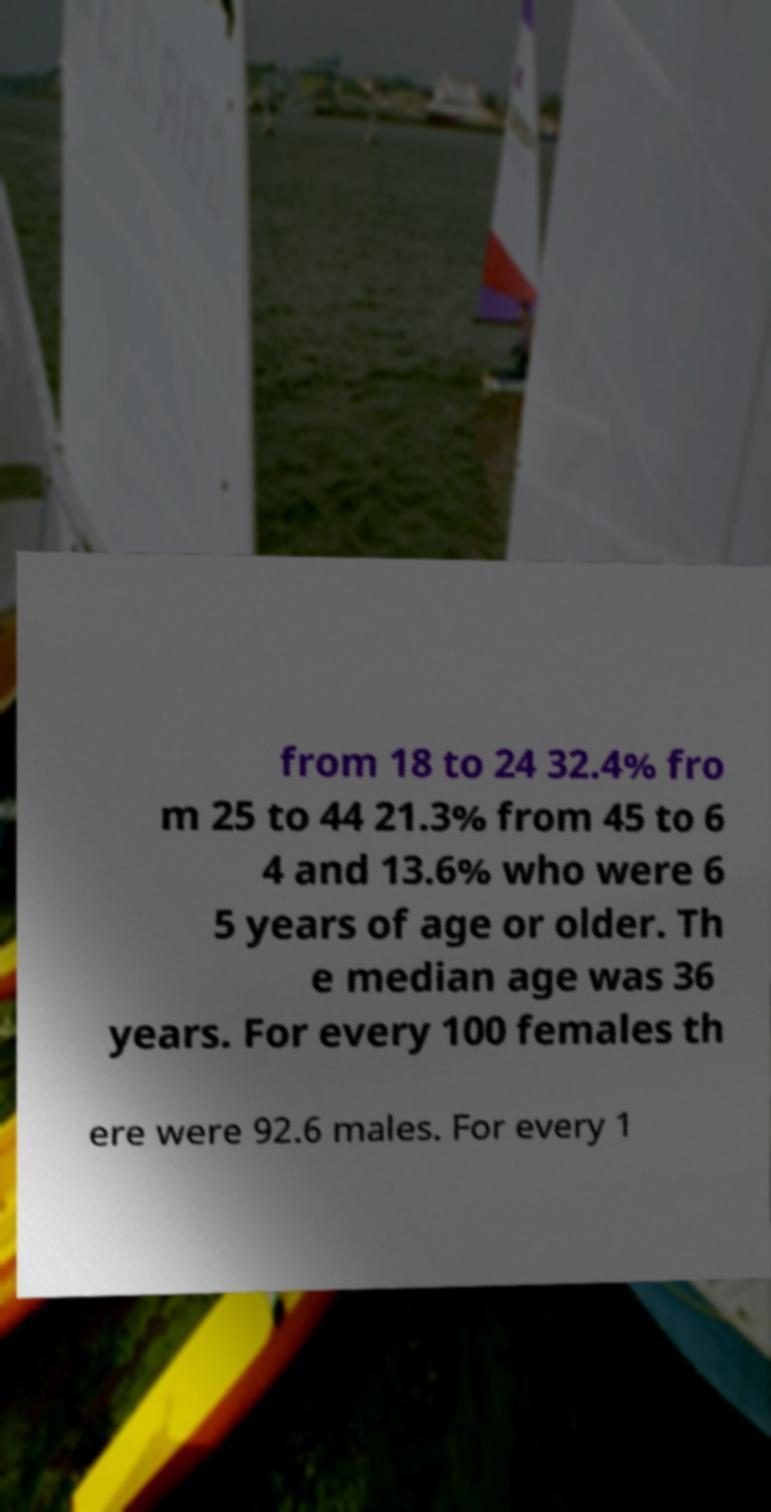Can you read and provide the text displayed in the image?This photo seems to have some interesting text. Can you extract and type it out for me? from 18 to 24 32.4% fro m 25 to 44 21.3% from 45 to 6 4 and 13.6% who were 6 5 years of age or older. Th e median age was 36 years. For every 100 females th ere were 92.6 males. For every 1 